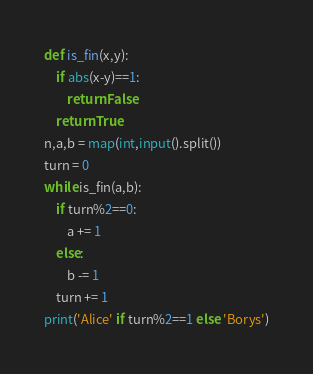Convert code to text. <code><loc_0><loc_0><loc_500><loc_500><_Python_>def is_fin(x,y):
    if abs(x-y)==1:
        return False
    return True
n,a,b = map(int,input().split())
turn = 0
while is_fin(a,b):
    if turn%2==0:
        a += 1
    else:
        b -= 1
    turn += 1
print('Alice' if turn%2==1 else 'Borys')</code> 